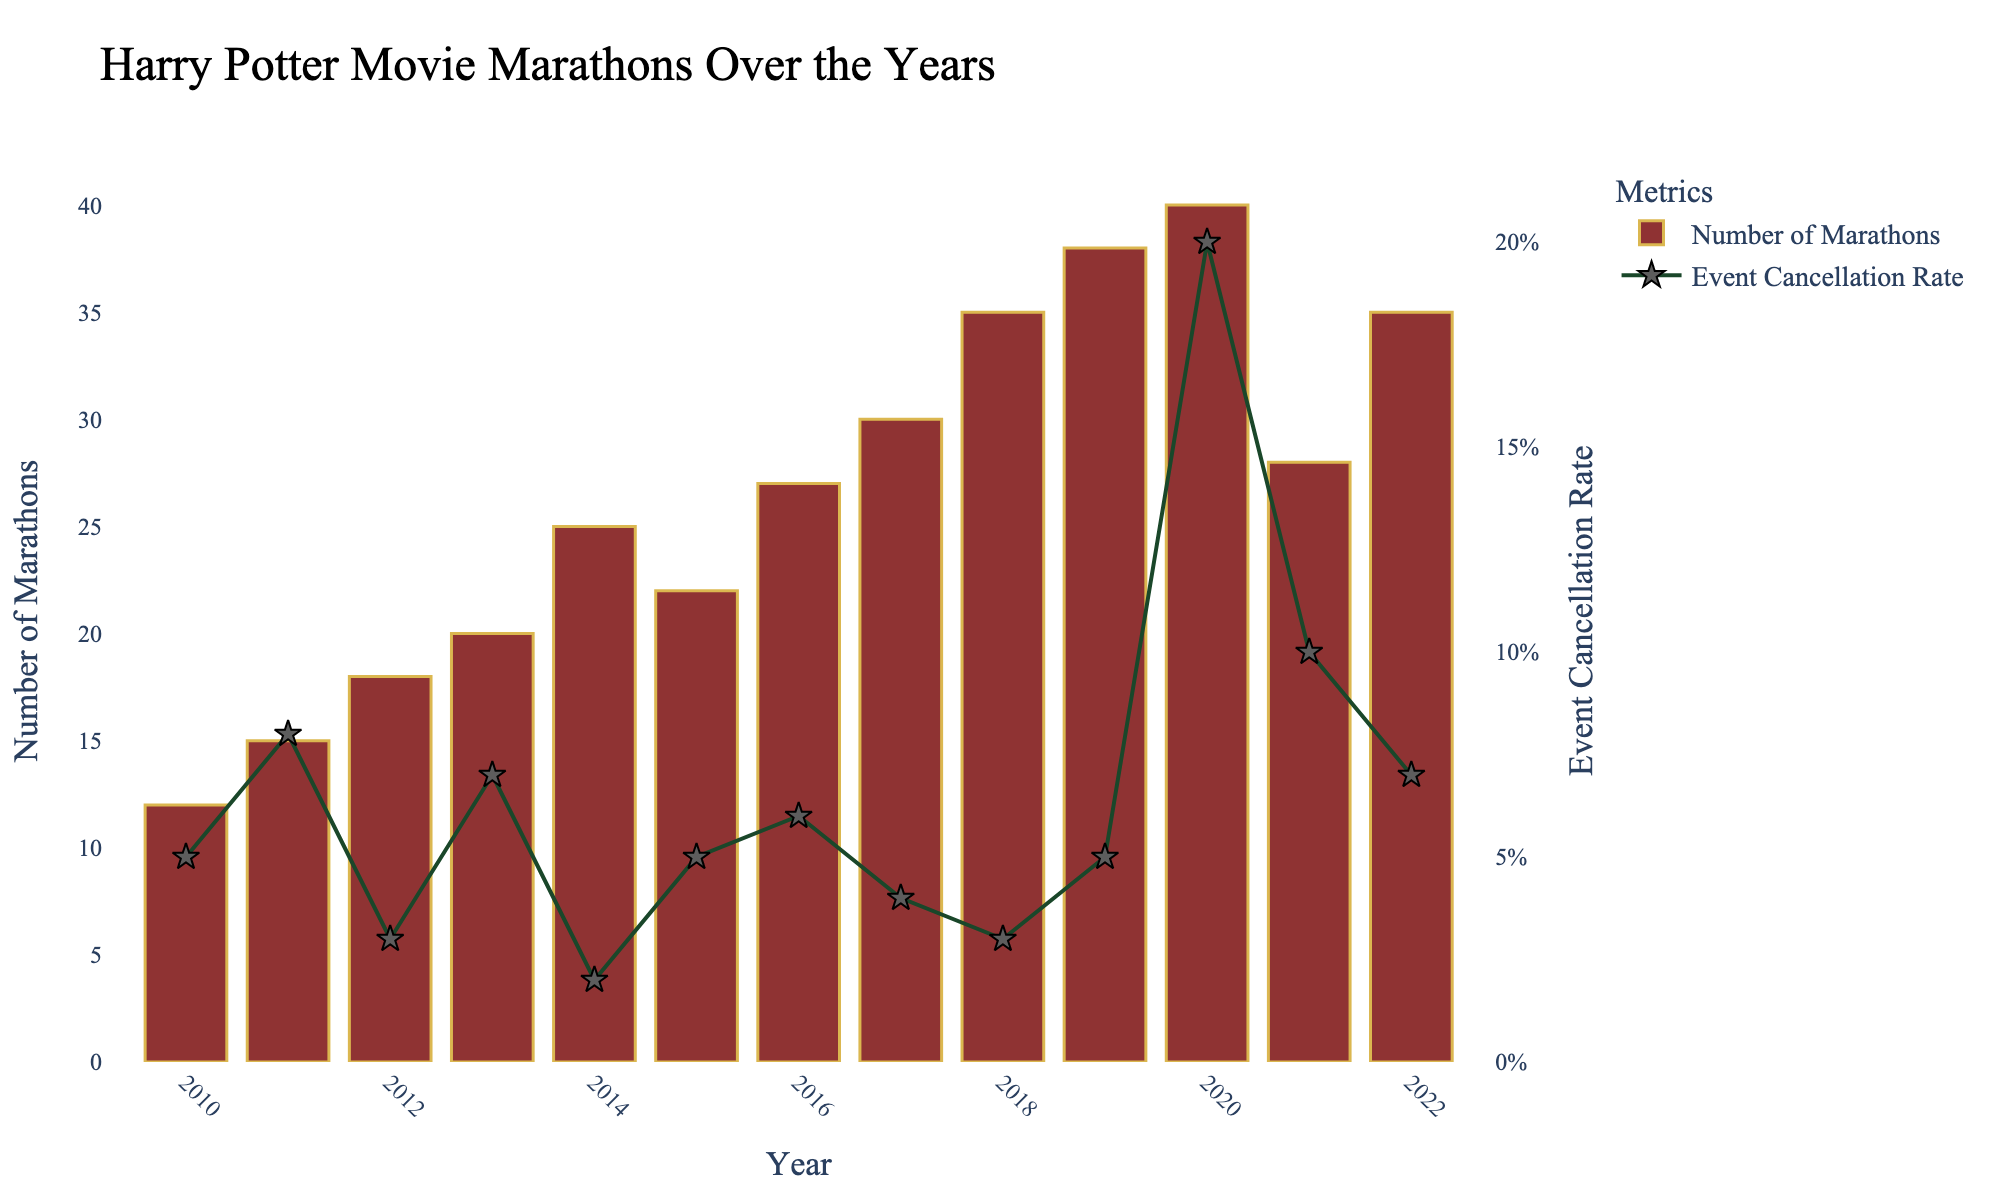What is the title of the plot? The title is displayed at the top of the figure and typically summarizes what the plot is about. In this case, the title reads "Harry Potter Movie Marathons Over the Years".
Answer: Harry Potter Movie Marathons Over the Years What do the bar colors in the chart represent? The bars are colored in a shade of red and visually represent the "Number of Marathons" held each year.
Answer: Number of Marathons What year had the highest number of Harry Potter movie marathons? To answer this, you observe the height of the bars and find that the tallest one corresponds to the year 2020, which represents the highest number of marathons held.
Answer: 2020 How does the Event Cancellation Rate in 2020 compare to other years? By looking at the green line with star markers, you can see that the Event Cancellation Rate in 2020 is noticeably higher than in other years, reaching around 20%.
Answer: Higher Which year had the lowest event cancellation rate and what was it? To find this, observe the lowest point on the green line. From the plot, 2014 has the lowest event cancellation rate of around 2%.
Answer: 2014, 0.02 How did the number of marathons change from 2010 to 2020? By comparing the heights of the bars for 2010 and 2020, you see an increase from 12 marathons in 2010 to 40 marathons in 2020.
Answer: Increased What's the trend in the number of Harry Potter movie marathons from 2010 to 2020? By looking at the overall shape of the bar chart, you can see that the number of marathons generally increased over the years from 2010 to 2020.
Answer: Increasing Which year experienced a significant drop in the number of marathons compared to the previous year, and how many were held? By comparing the bars year by year, 2021 saw a significant drop from 40 marathons in 2020 to 28 marathons.
Answer: 2021, 28 What is the average event cancellation rate from 2010 to 2022? To find the average, add up all the event cancellation rates and divide by the number of years. (0.05 + 0.08 + 0.03 + 0.07 + 0.02 + 0.05 + 0.06 + 0.04 + 0.03 + 0.05 + 0.20 + 0.10 + 0.07) / 13 = 0.065, or 6.5%.
Answer: 6.5% Looking at the data, which years had a cancellation rate greater than the average rate, and what does this imply? From the calculated average of 6.5%, years with a higher rate than this include 2011 (0.08), 2013 (0.07), 2016 (0.06), 2020 (0.20), 2021 (0.10), and 2022 (0.07). This implies greater disruption in these years compared to others.
Answer: 2011, 2013, 2016, 2020, 2021, 2022 